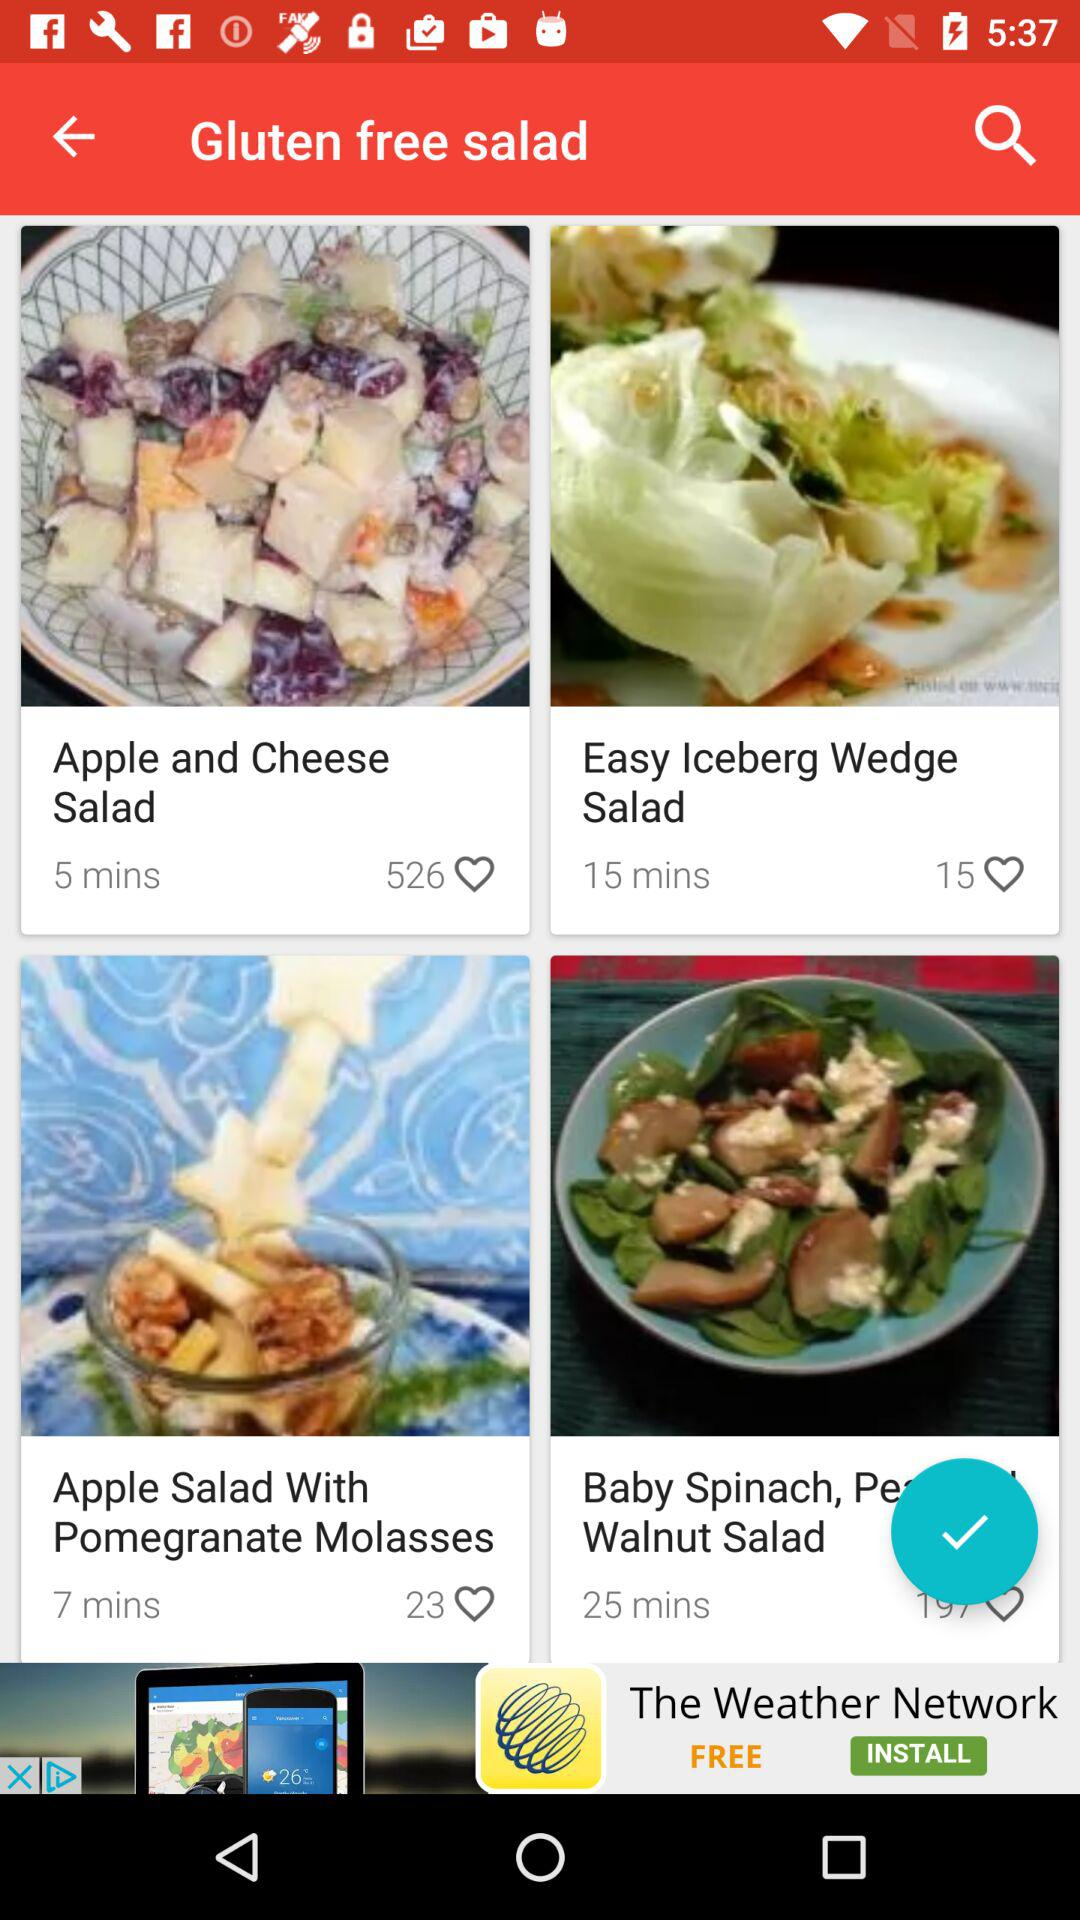What is the number of likes of Easy Iceberg Wedge Salad? The number of likes is 15. 